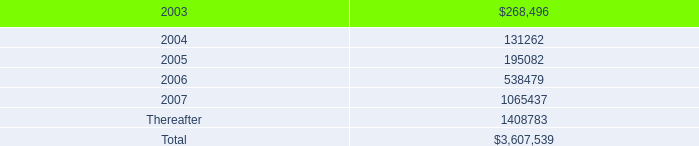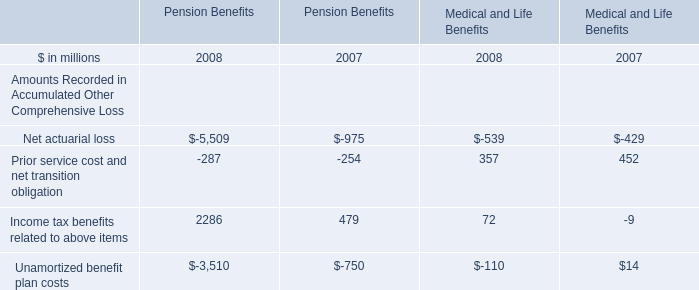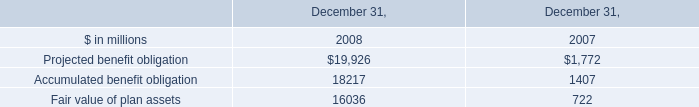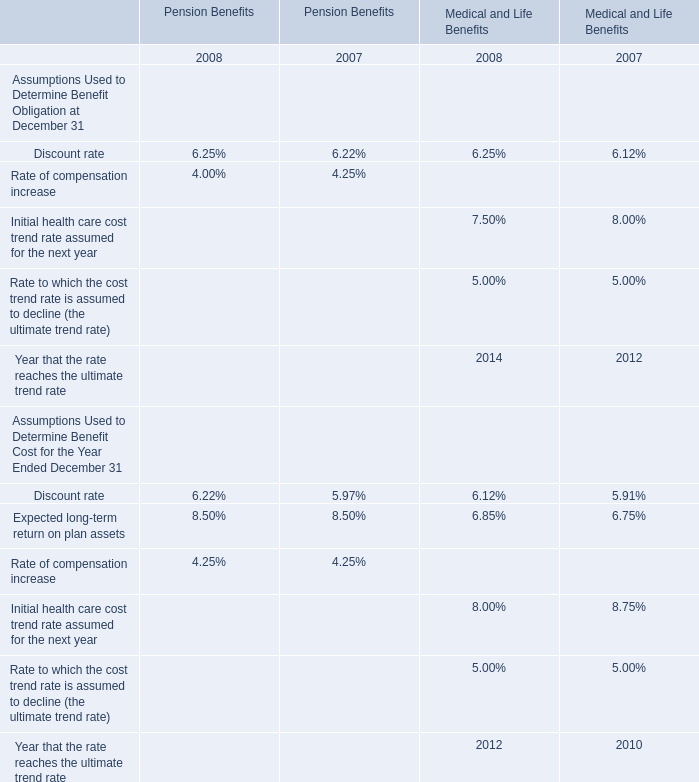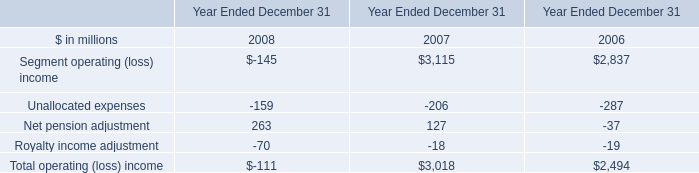If Income tax benefits related to above items develops with the same increasing rate in 2007, what will it reach in 2008? (in million) 
Computations: (2286 * (1 + (2286 - 479)))
Answer: 4133088.0. 